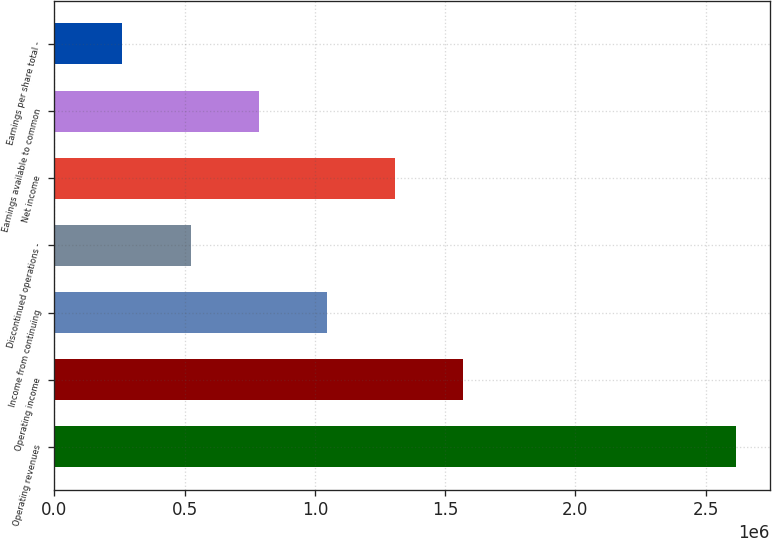<chart> <loc_0><loc_0><loc_500><loc_500><bar_chart><fcel>Operating revenues<fcel>Operating income<fcel>Income from continuing<fcel>Discontinued operations -<fcel>Net income<fcel>Earnings available to common<fcel>Earnings per share total -<nl><fcel>2.61552e+06<fcel>1.56931e+06<fcel>1.04621e+06<fcel>523103<fcel>1.30776e+06<fcel>784655<fcel>261552<nl></chart> 